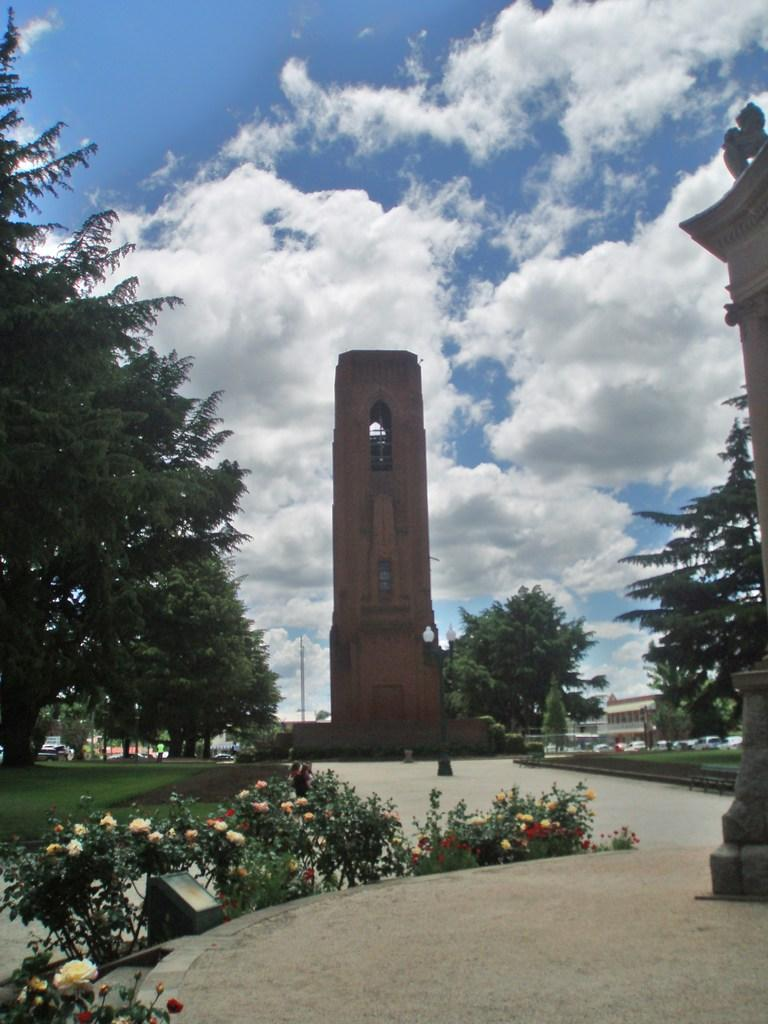What types of vegetation can be seen in the image? There are plants and trees in the image. What type of structure is present in the image? There is a building in the image. What covers the ground in some areas of the image? There is grass on the ground in some areas of the image. What color is the sky in the image? The sky is blue and visible at the top of the image. What else can be seen in the sky? There are clouds in the sky. What type of curtain is hanging in the trees in the image? There is no curtain present in the image; it features plants, trees, a building, grass, and a blue sky with clouds. What is the need for pollution in the image? There is no mention of pollution in the image, and it is not relevant to the scene depicted. 